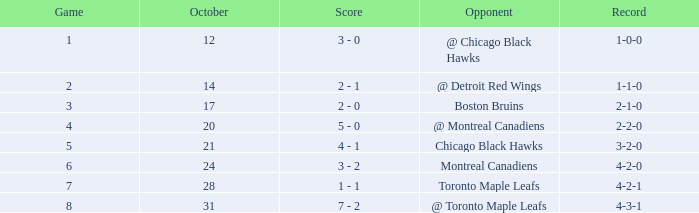What was the score of the game after game 6 on October 28? 1 - 1. 